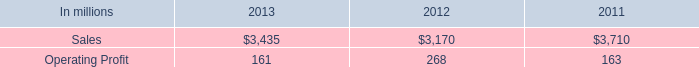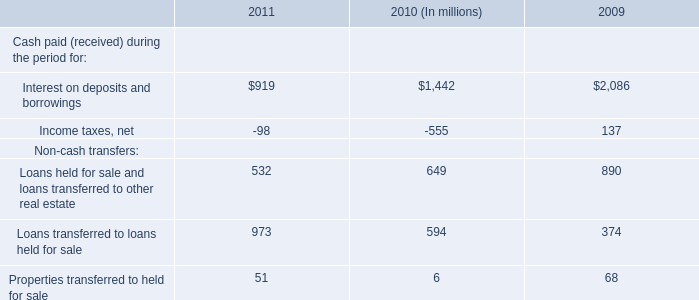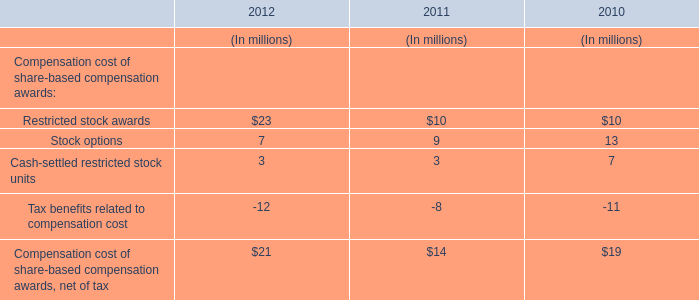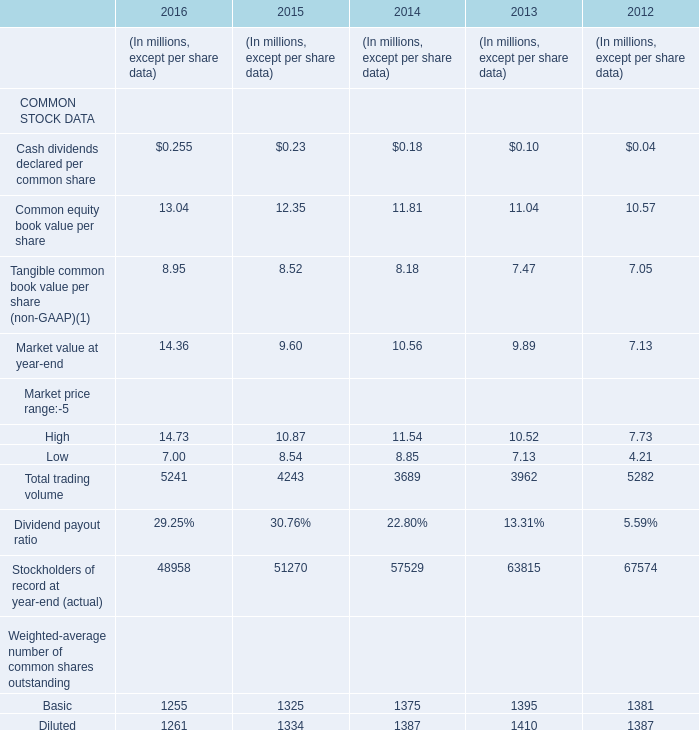In the year with largest amount of Cash dividends declared per common share, what's the sum of Tangible common book value per share and Market value at year-end (in million) 
Computations: (8.95 + 14.36)
Answer: 23.31. 